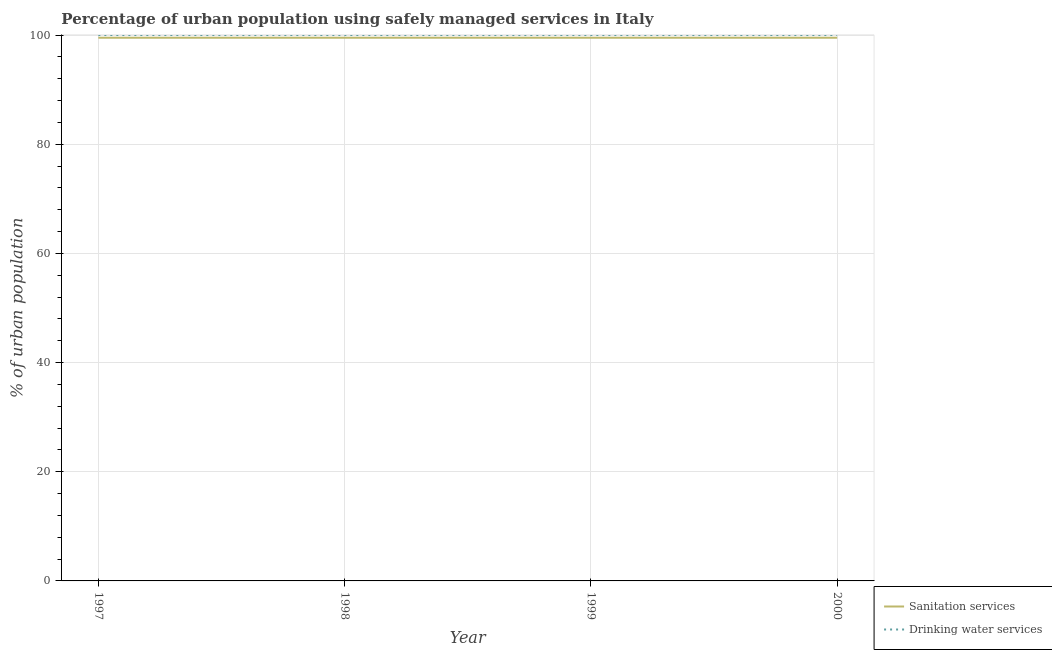Is the number of lines equal to the number of legend labels?
Provide a short and direct response. Yes. What is the percentage of urban population who used sanitation services in 2000?
Provide a short and direct response. 99.5. Across all years, what is the maximum percentage of urban population who used sanitation services?
Your answer should be compact. 99.5. Across all years, what is the minimum percentage of urban population who used sanitation services?
Provide a succinct answer. 99.5. In which year was the percentage of urban population who used sanitation services maximum?
Provide a short and direct response. 1997. What is the total percentage of urban population who used drinking water services in the graph?
Provide a short and direct response. 400. What is the difference between the percentage of urban population who used sanitation services in 1997 and that in 2000?
Ensure brevity in your answer.  0. What is the average percentage of urban population who used sanitation services per year?
Give a very brief answer. 99.5. In the year 1997, what is the difference between the percentage of urban population who used sanitation services and percentage of urban population who used drinking water services?
Offer a very short reply. -0.5. Is the percentage of urban population who used drinking water services in 1998 less than that in 1999?
Your response must be concise. No. What is the difference between the highest and the lowest percentage of urban population who used drinking water services?
Offer a very short reply. 0. Is the percentage of urban population who used sanitation services strictly greater than the percentage of urban population who used drinking water services over the years?
Offer a terse response. No. What is the difference between two consecutive major ticks on the Y-axis?
Offer a terse response. 20. Are the values on the major ticks of Y-axis written in scientific E-notation?
Keep it short and to the point. No. Does the graph contain any zero values?
Offer a very short reply. No. Where does the legend appear in the graph?
Your answer should be very brief. Bottom right. What is the title of the graph?
Your answer should be compact. Percentage of urban population using safely managed services in Italy. Does "Money lenders" appear as one of the legend labels in the graph?
Give a very brief answer. No. What is the label or title of the X-axis?
Offer a very short reply. Year. What is the label or title of the Y-axis?
Ensure brevity in your answer.  % of urban population. What is the % of urban population in Sanitation services in 1997?
Provide a short and direct response. 99.5. What is the % of urban population of Sanitation services in 1998?
Make the answer very short. 99.5. What is the % of urban population of Sanitation services in 1999?
Your answer should be very brief. 99.5. What is the % of urban population of Sanitation services in 2000?
Your answer should be very brief. 99.5. What is the % of urban population in Drinking water services in 2000?
Your answer should be compact. 100. Across all years, what is the maximum % of urban population of Sanitation services?
Give a very brief answer. 99.5. Across all years, what is the maximum % of urban population of Drinking water services?
Offer a very short reply. 100. Across all years, what is the minimum % of urban population of Sanitation services?
Your answer should be very brief. 99.5. What is the total % of urban population in Sanitation services in the graph?
Make the answer very short. 398. What is the total % of urban population in Drinking water services in the graph?
Give a very brief answer. 400. What is the difference between the % of urban population of Drinking water services in 1997 and that in 1998?
Your answer should be very brief. 0. What is the difference between the % of urban population in Sanitation services in 1997 and that in 1999?
Give a very brief answer. 0. What is the difference between the % of urban population of Sanitation services in 1998 and that in 1999?
Provide a succinct answer. 0. What is the difference between the % of urban population of Sanitation services in 1998 and that in 2000?
Offer a terse response. 0. What is the difference between the % of urban population in Drinking water services in 1998 and that in 2000?
Your answer should be very brief. 0. What is the difference between the % of urban population in Sanitation services in 1999 and that in 2000?
Provide a succinct answer. 0. What is the difference between the % of urban population in Drinking water services in 1999 and that in 2000?
Give a very brief answer. 0. What is the difference between the % of urban population in Sanitation services in 1997 and the % of urban population in Drinking water services in 1998?
Provide a short and direct response. -0.5. What is the difference between the % of urban population in Sanitation services in 1997 and the % of urban population in Drinking water services in 2000?
Offer a terse response. -0.5. What is the difference between the % of urban population of Sanitation services in 1998 and the % of urban population of Drinking water services in 1999?
Give a very brief answer. -0.5. What is the average % of urban population of Sanitation services per year?
Offer a very short reply. 99.5. In the year 2000, what is the difference between the % of urban population in Sanitation services and % of urban population in Drinking water services?
Your answer should be compact. -0.5. What is the ratio of the % of urban population of Sanitation services in 1997 to that in 1998?
Make the answer very short. 1. What is the ratio of the % of urban population of Drinking water services in 1997 to that in 1998?
Provide a short and direct response. 1. What is the ratio of the % of urban population in Sanitation services in 1997 to that in 2000?
Provide a succinct answer. 1. What is the ratio of the % of urban population of Drinking water services in 1997 to that in 2000?
Your response must be concise. 1. What is the ratio of the % of urban population in Sanitation services in 1998 to that in 1999?
Offer a very short reply. 1. What is the ratio of the % of urban population in Sanitation services in 1998 to that in 2000?
Offer a very short reply. 1. What is the ratio of the % of urban population of Drinking water services in 1998 to that in 2000?
Your answer should be compact. 1. What is the difference between the highest and the second highest % of urban population of Drinking water services?
Your answer should be compact. 0. What is the difference between the highest and the lowest % of urban population of Drinking water services?
Your answer should be compact. 0. 